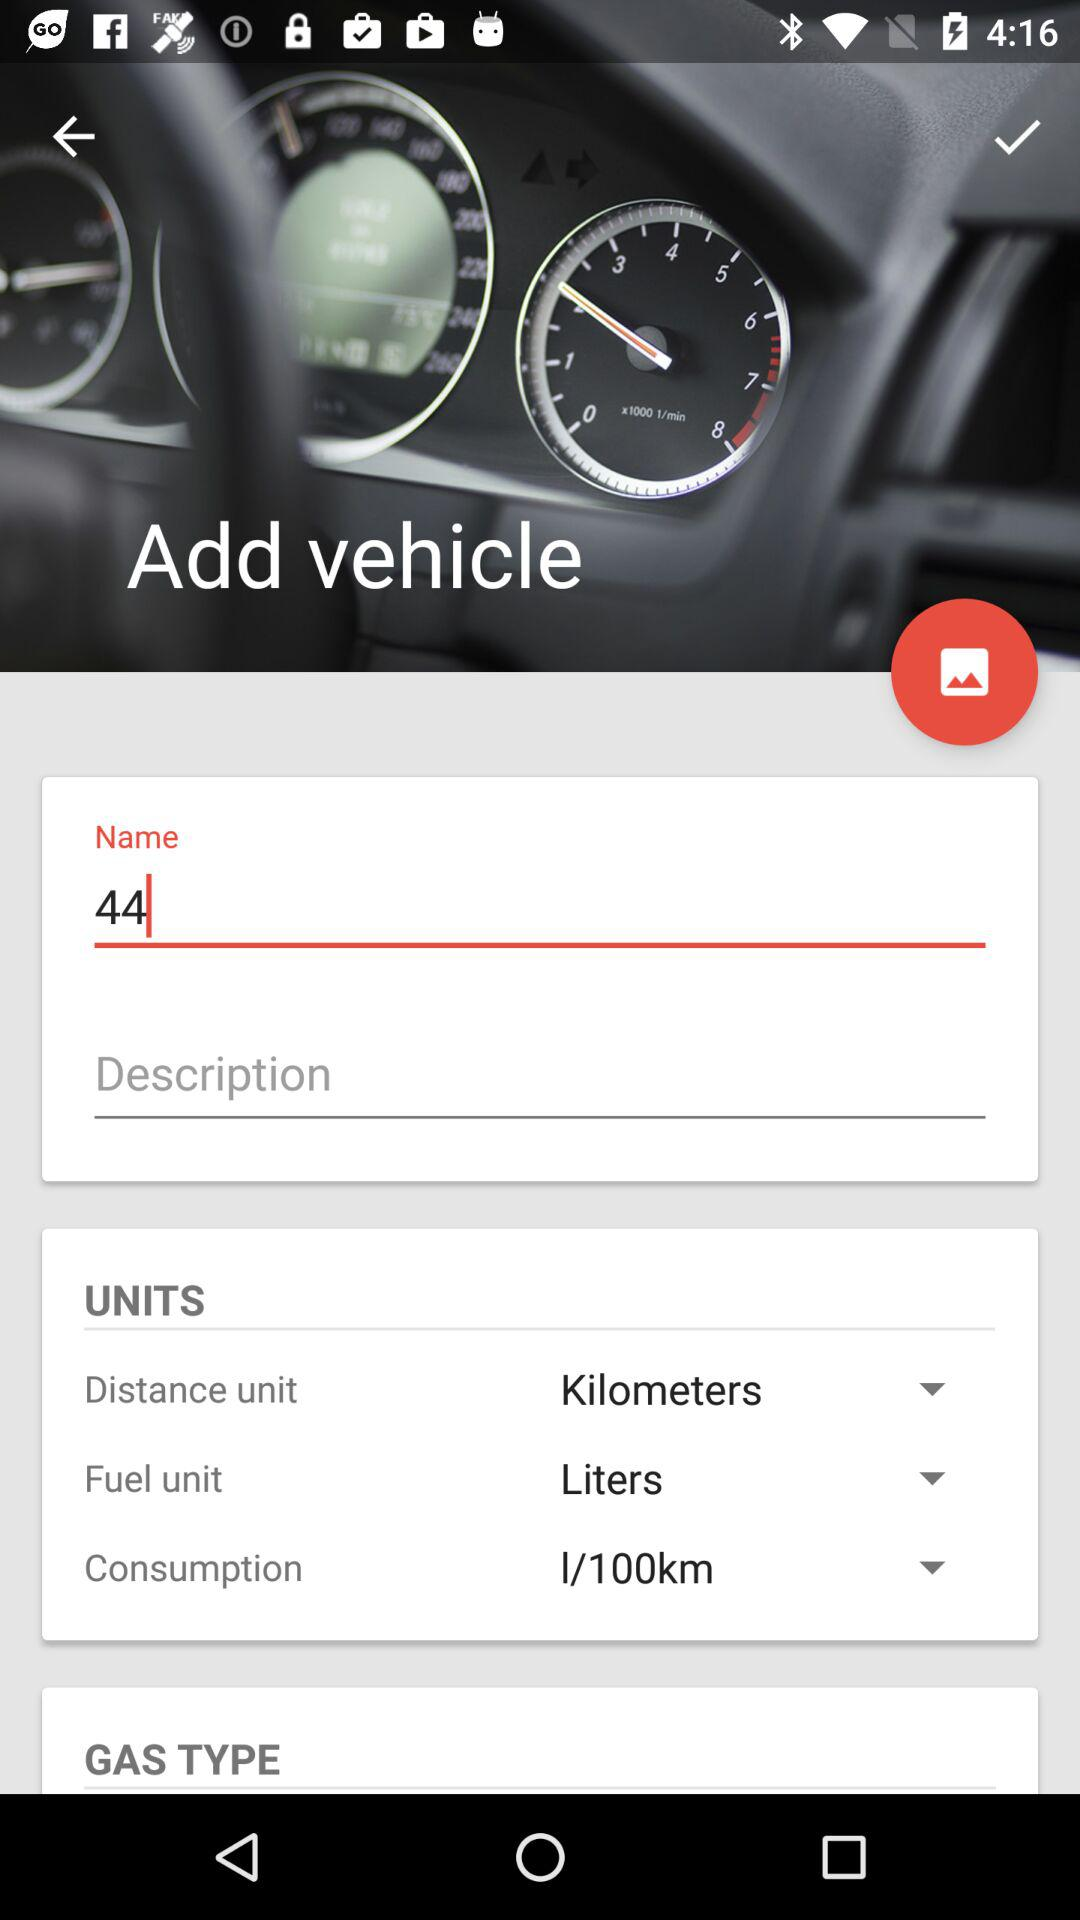What is the rate of consumption? The rate of consumption is 1 litre per 100 kilometers. 